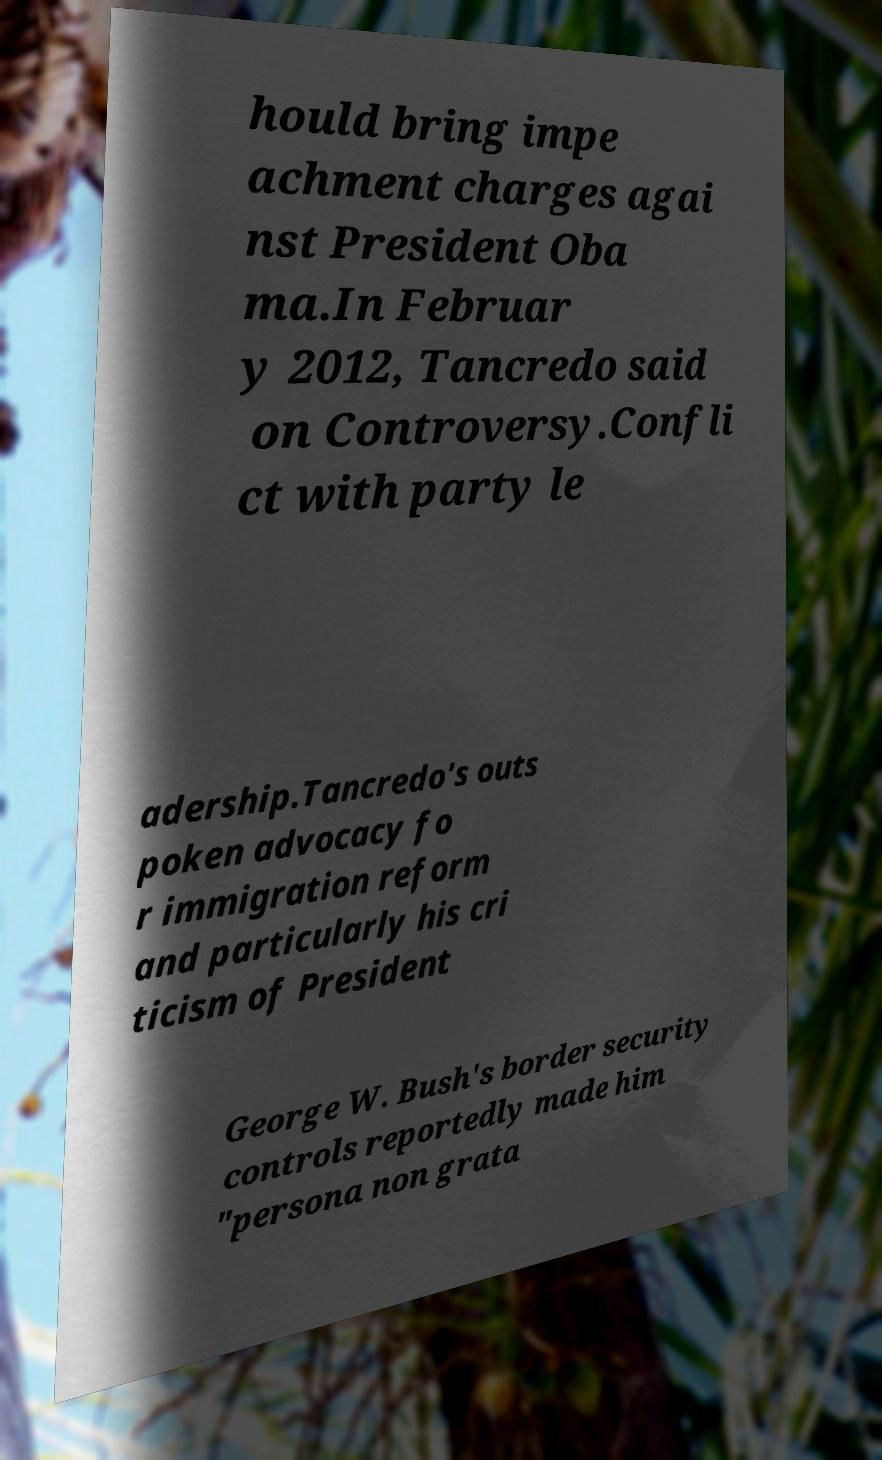Could you extract and type out the text from this image? hould bring impe achment charges agai nst President Oba ma.In Februar y 2012, Tancredo said on Controversy.Confli ct with party le adership.Tancredo's outs poken advocacy fo r immigration reform and particularly his cri ticism of President George W. Bush's border security controls reportedly made him "persona non grata 